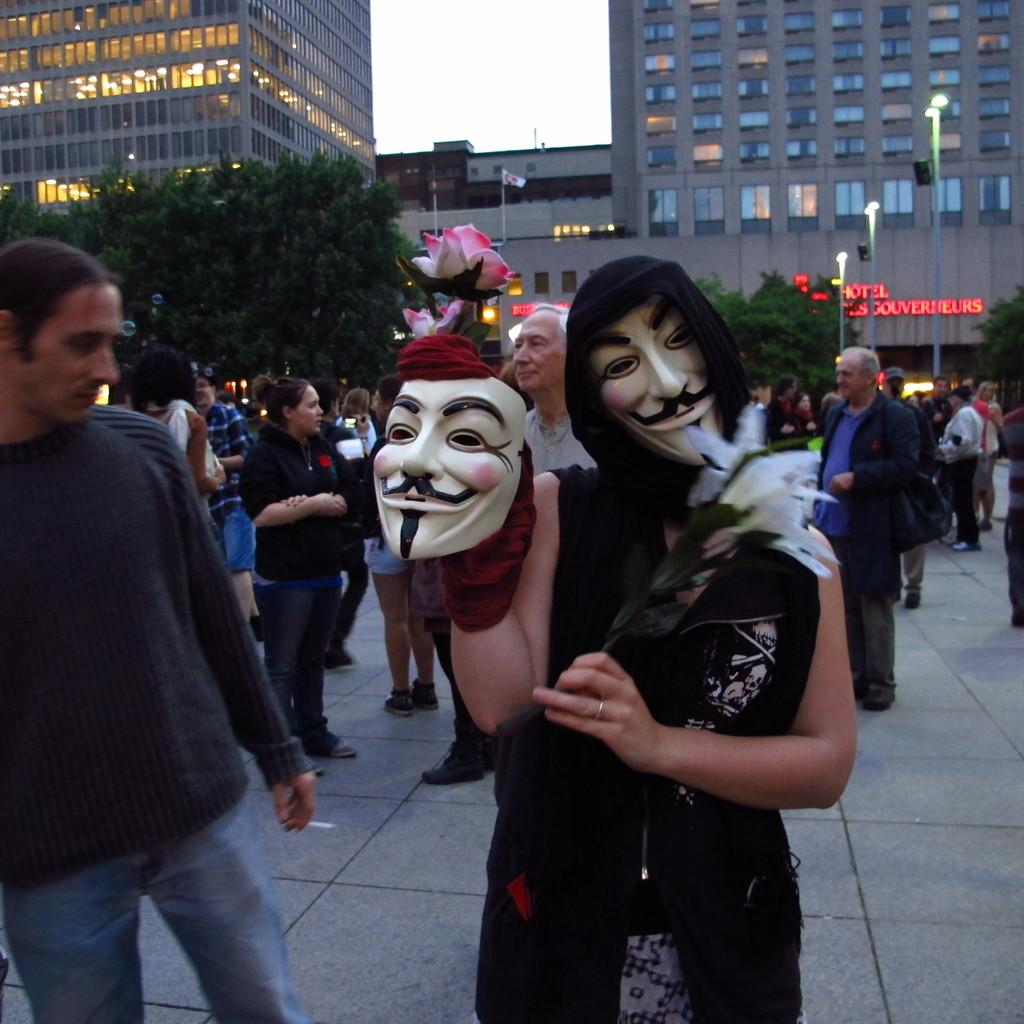How many people are visible in the image? There are many people in the image. Can you describe the woman in the front of the image? A woman is wearing a mask in the front of the image. What can be seen in the background of the image? There are buildings in the background of the image. What is the surface on which the people are standing? There is a floor at the bottom of the image. What is the temperature of the scene in the image? The provided facts do not mention the temperature or any indication of the scene's temperature, so it cannot be determined from the image. 